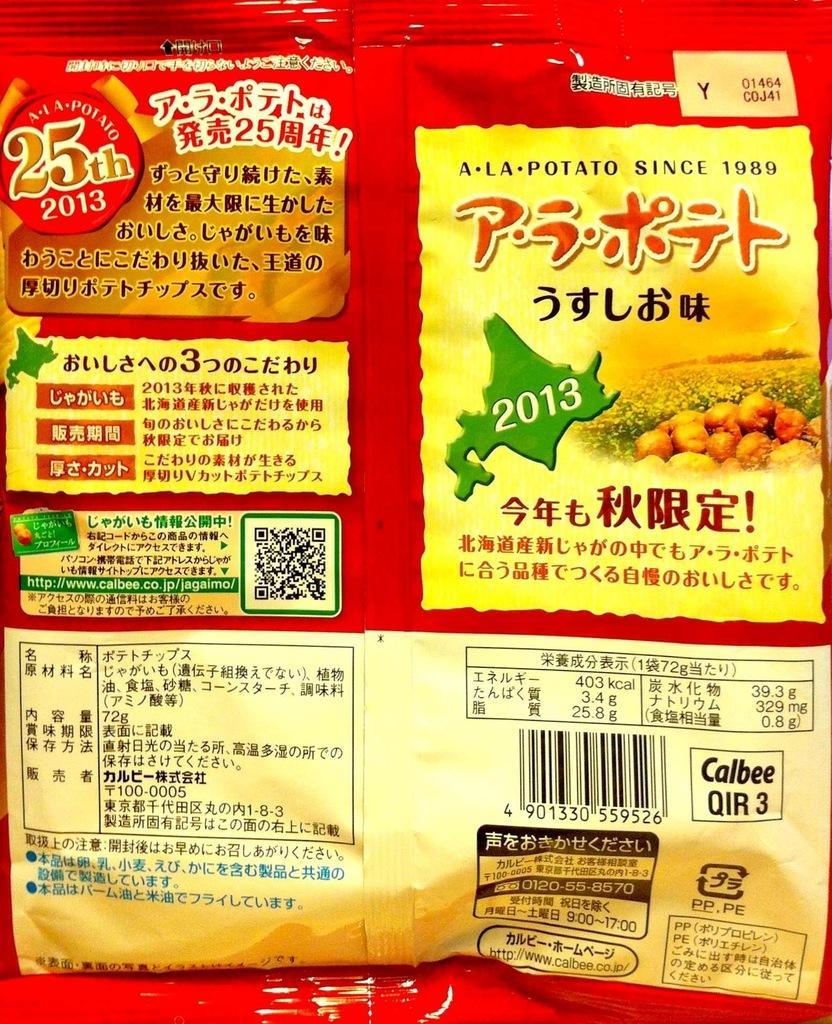How would you summarize this image in a sentence or two? In this image we can see a red color packet with the text, barcode and also the price. 